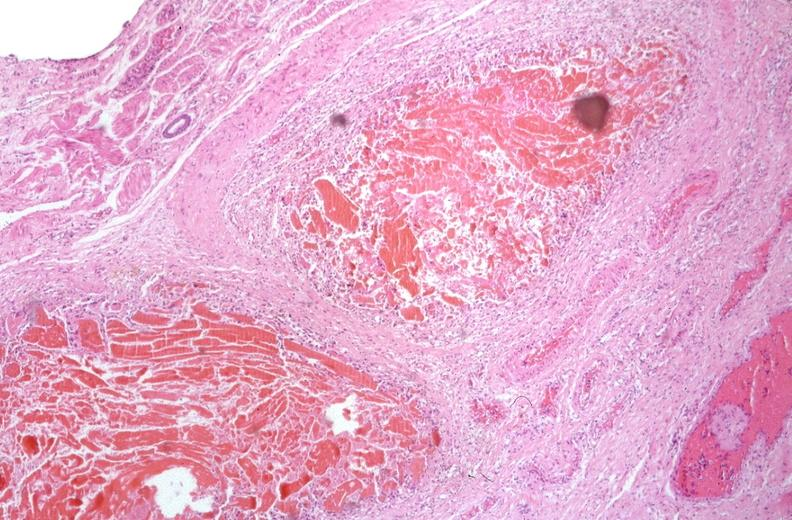does this image show esophogus, varices portal hypertension due to cirrhosis, hcv?
Answer the question using a single word or phrase. Yes 